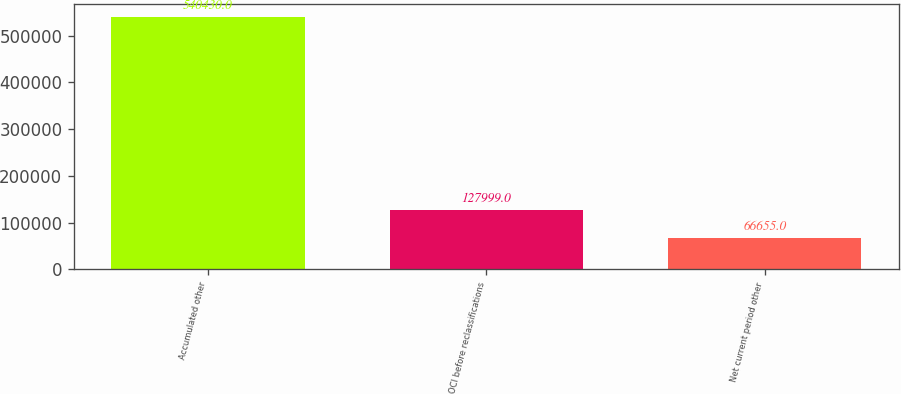Convert chart. <chart><loc_0><loc_0><loc_500><loc_500><bar_chart><fcel>Accumulated other<fcel>OCI before reclassifications<fcel>Net current period other<nl><fcel>540430<fcel>127999<fcel>66655<nl></chart> 